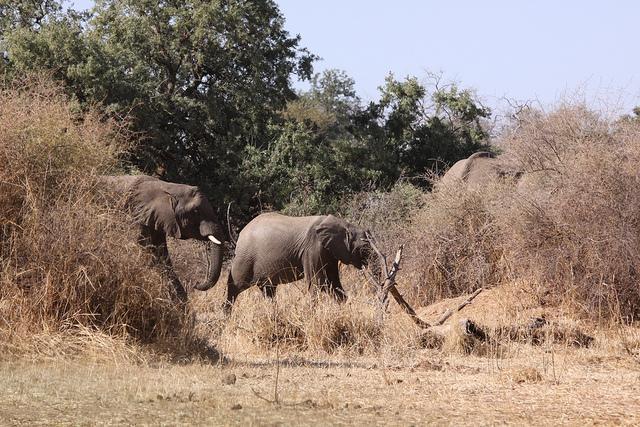How many elephants are in this photo?
Give a very brief answer. 2. How many elephants are there?
Give a very brief answer. 2. 